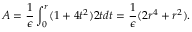Convert formula to latex. <formula><loc_0><loc_0><loc_500><loc_500>A = { \frac { 1 } { \epsilon } } \int _ { 0 } ^ { r } ( 1 + 4 t ^ { 2 } ) 2 t d t = { \frac { 1 } { \epsilon } } ( 2 r ^ { 4 } + r ^ { 2 } ) .</formula> 